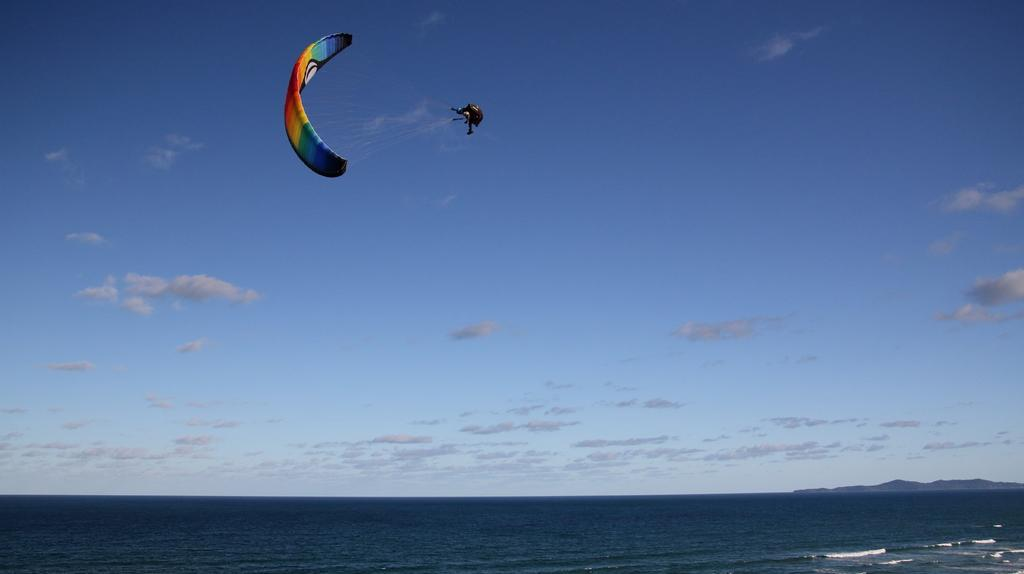Who is present in the image? There is a person in the image. What is the person wearing in the image? The person is wearing a parachute in the image. What natural feature can be seen in the image? There is an ocean in the image. What is the condition of the sky in the image? The sky is clear in the image. Where is the person's mom in the image? There is no mention of a mom in the image, so we cannot determine her location. How many spiders are crawling on the person's parachute in the image? There are no spiders present in the image, so we cannot determine their number. 